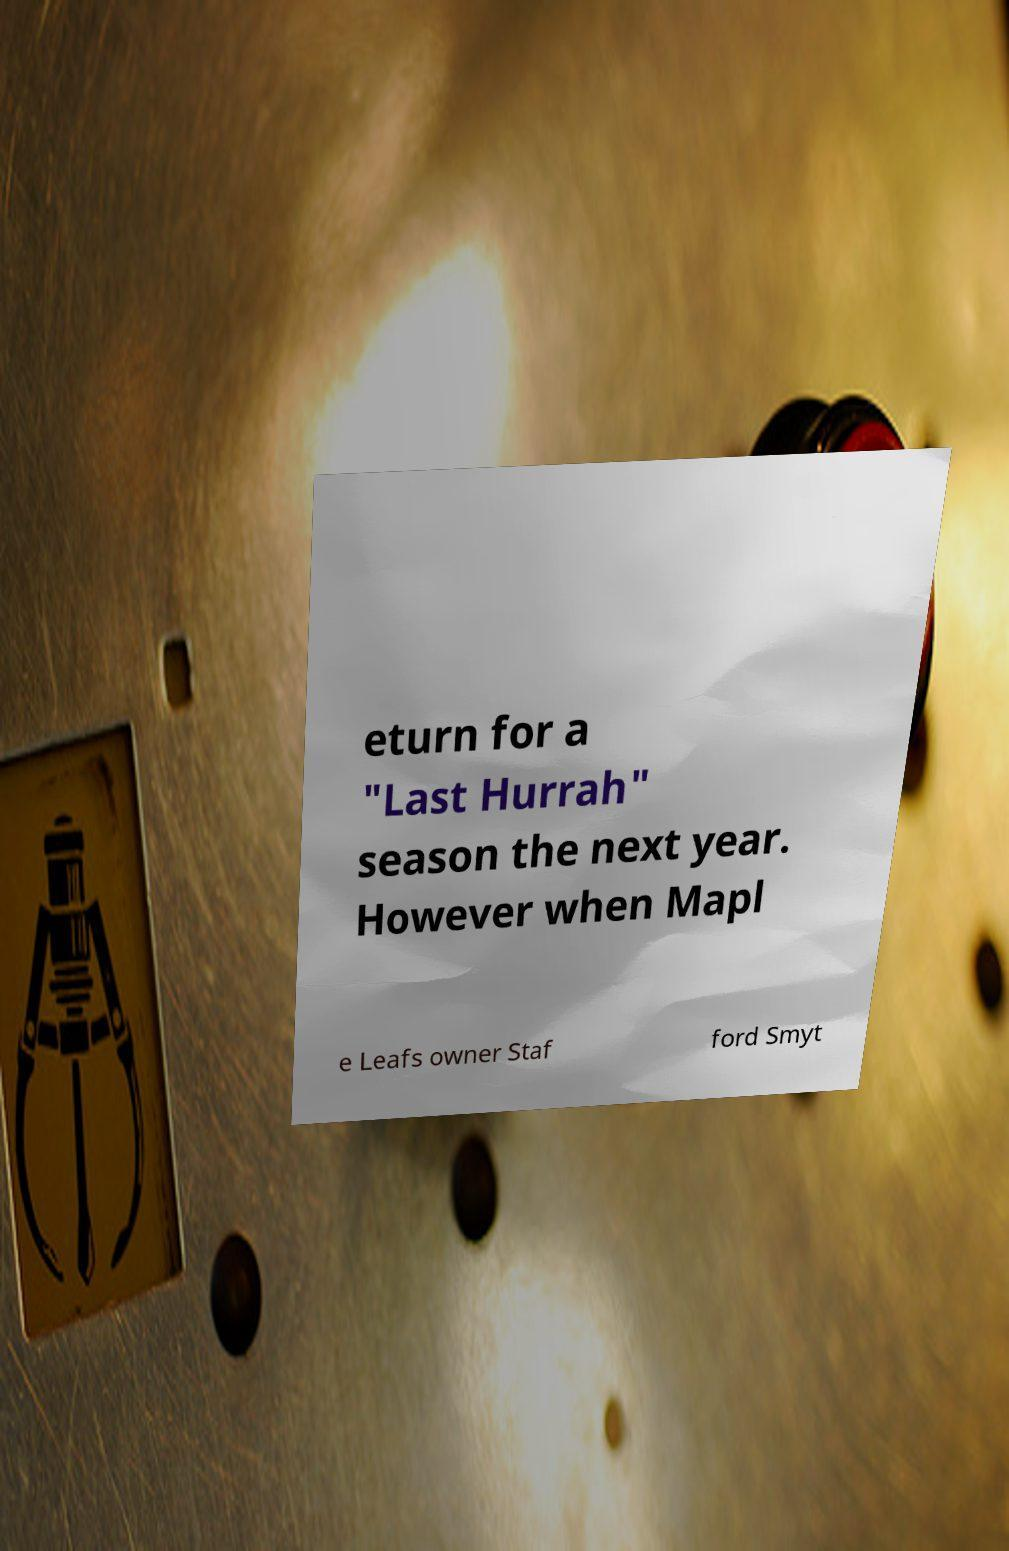Could you assist in decoding the text presented in this image and type it out clearly? eturn for a "Last Hurrah" season the next year. However when Mapl e Leafs owner Staf ford Smyt 